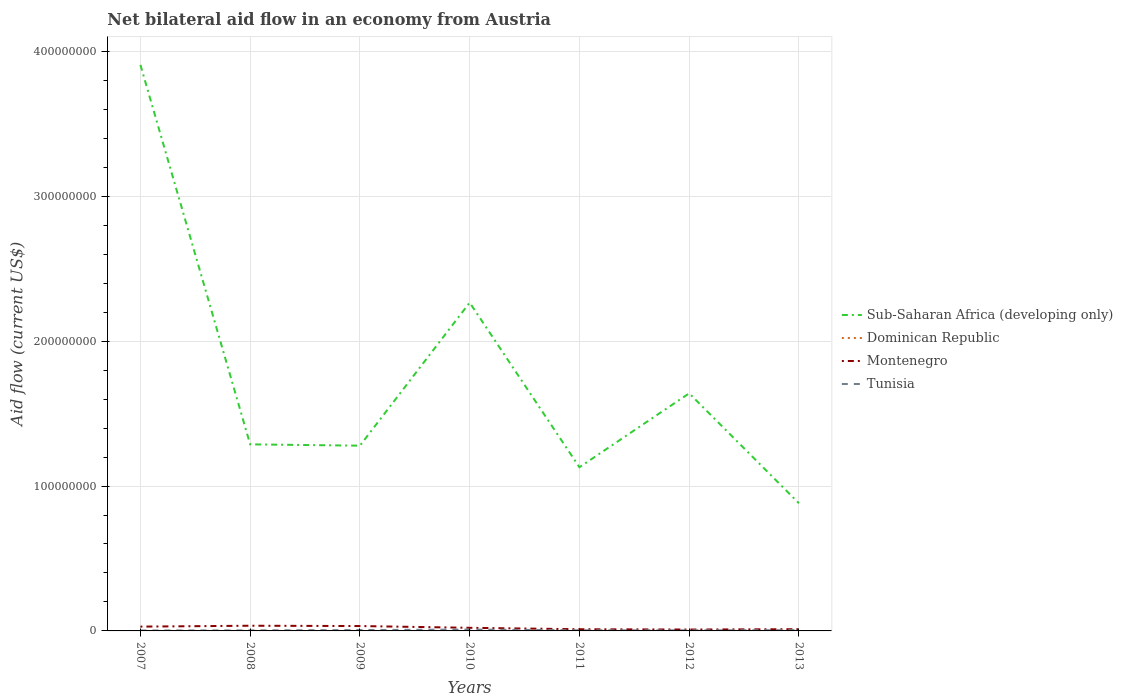How many different coloured lines are there?
Your answer should be compact. 4. Is the number of lines equal to the number of legend labels?
Your answer should be very brief. Yes. Across all years, what is the maximum net bilateral aid flow in Montenegro?
Your response must be concise. 9.60e+05. In which year was the net bilateral aid flow in Tunisia maximum?
Give a very brief answer. 2007. What is the total net bilateral aid flow in Sub-Saharan Africa (developing only) in the graph?
Make the answer very short. 2.62e+08. What is the difference between the highest and the second highest net bilateral aid flow in Montenegro?
Provide a succinct answer. 2.62e+06. What is the difference between the highest and the lowest net bilateral aid flow in Dominican Republic?
Offer a terse response. 3. How many years are there in the graph?
Your response must be concise. 7. Are the values on the major ticks of Y-axis written in scientific E-notation?
Your answer should be compact. No. Where does the legend appear in the graph?
Your answer should be very brief. Center right. How many legend labels are there?
Give a very brief answer. 4. How are the legend labels stacked?
Offer a terse response. Vertical. What is the title of the graph?
Your response must be concise. Net bilateral aid flow in an economy from Austria. Does "Morocco" appear as one of the legend labels in the graph?
Provide a short and direct response. No. What is the label or title of the X-axis?
Keep it short and to the point. Years. What is the label or title of the Y-axis?
Keep it short and to the point. Aid flow (current US$). What is the Aid flow (current US$) in Sub-Saharan Africa (developing only) in 2007?
Offer a very short reply. 3.91e+08. What is the Aid flow (current US$) in Dominican Republic in 2007?
Keep it short and to the point. 10000. What is the Aid flow (current US$) of Montenegro in 2007?
Offer a terse response. 2.97e+06. What is the Aid flow (current US$) in Tunisia in 2007?
Your answer should be very brief. 2.70e+05. What is the Aid flow (current US$) of Sub-Saharan Africa (developing only) in 2008?
Make the answer very short. 1.29e+08. What is the Aid flow (current US$) of Montenegro in 2008?
Your answer should be compact. 3.58e+06. What is the Aid flow (current US$) of Tunisia in 2008?
Your response must be concise. 3.70e+05. What is the Aid flow (current US$) in Sub-Saharan Africa (developing only) in 2009?
Offer a terse response. 1.28e+08. What is the Aid flow (current US$) of Dominican Republic in 2009?
Make the answer very short. 10000. What is the Aid flow (current US$) in Montenegro in 2009?
Keep it short and to the point. 3.37e+06. What is the Aid flow (current US$) in Sub-Saharan Africa (developing only) in 2010?
Keep it short and to the point. 2.27e+08. What is the Aid flow (current US$) of Dominican Republic in 2010?
Provide a succinct answer. 2.00e+04. What is the Aid flow (current US$) of Montenegro in 2010?
Make the answer very short. 2.15e+06. What is the Aid flow (current US$) in Tunisia in 2010?
Your answer should be very brief. 9.50e+05. What is the Aid flow (current US$) of Sub-Saharan Africa (developing only) in 2011?
Your response must be concise. 1.13e+08. What is the Aid flow (current US$) in Montenegro in 2011?
Provide a succinct answer. 1.16e+06. What is the Aid flow (current US$) of Sub-Saharan Africa (developing only) in 2012?
Offer a terse response. 1.64e+08. What is the Aid flow (current US$) in Dominican Republic in 2012?
Make the answer very short. 4.00e+04. What is the Aid flow (current US$) of Montenegro in 2012?
Give a very brief answer. 9.60e+05. What is the Aid flow (current US$) of Tunisia in 2012?
Keep it short and to the point. 4.00e+05. What is the Aid flow (current US$) of Sub-Saharan Africa (developing only) in 2013?
Keep it short and to the point. 8.81e+07. What is the Aid flow (current US$) in Dominican Republic in 2013?
Offer a terse response. 3.00e+04. What is the Aid flow (current US$) in Montenegro in 2013?
Make the answer very short. 1.19e+06. What is the Aid flow (current US$) in Tunisia in 2013?
Offer a very short reply. 5.30e+05. Across all years, what is the maximum Aid flow (current US$) of Sub-Saharan Africa (developing only)?
Your answer should be very brief. 3.91e+08. Across all years, what is the maximum Aid flow (current US$) of Dominican Republic?
Provide a short and direct response. 4.00e+04. Across all years, what is the maximum Aid flow (current US$) in Montenegro?
Your response must be concise. 3.58e+06. Across all years, what is the maximum Aid flow (current US$) in Tunisia?
Give a very brief answer. 9.50e+05. Across all years, what is the minimum Aid flow (current US$) of Sub-Saharan Africa (developing only)?
Your answer should be compact. 8.81e+07. Across all years, what is the minimum Aid flow (current US$) of Montenegro?
Provide a succinct answer. 9.60e+05. What is the total Aid flow (current US$) of Sub-Saharan Africa (developing only) in the graph?
Provide a succinct answer. 1.24e+09. What is the total Aid flow (current US$) in Montenegro in the graph?
Your answer should be compact. 1.54e+07. What is the total Aid flow (current US$) of Tunisia in the graph?
Ensure brevity in your answer.  3.56e+06. What is the difference between the Aid flow (current US$) in Sub-Saharan Africa (developing only) in 2007 and that in 2008?
Offer a terse response. 2.62e+08. What is the difference between the Aid flow (current US$) in Dominican Republic in 2007 and that in 2008?
Ensure brevity in your answer.  -10000. What is the difference between the Aid flow (current US$) in Montenegro in 2007 and that in 2008?
Offer a terse response. -6.10e+05. What is the difference between the Aid flow (current US$) in Sub-Saharan Africa (developing only) in 2007 and that in 2009?
Ensure brevity in your answer.  2.63e+08. What is the difference between the Aid flow (current US$) in Dominican Republic in 2007 and that in 2009?
Your response must be concise. 0. What is the difference between the Aid flow (current US$) in Montenegro in 2007 and that in 2009?
Your answer should be compact. -4.00e+05. What is the difference between the Aid flow (current US$) in Tunisia in 2007 and that in 2009?
Keep it short and to the point. -3.30e+05. What is the difference between the Aid flow (current US$) of Sub-Saharan Africa (developing only) in 2007 and that in 2010?
Keep it short and to the point. 1.64e+08. What is the difference between the Aid flow (current US$) in Montenegro in 2007 and that in 2010?
Your answer should be very brief. 8.20e+05. What is the difference between the Aid flow (current US$) of Tunisia in 2007 and that in 2010?
Make the answer very short. -6.80e+05. What is the difference between the Aid flow (current US$) of Sub-Saharan Africa (developing only) in 2007 and that in 2011?
Give a very brief answer. 2.78e+08. What is the difference between the Aid flow (current US$) of Montenegro in 2007 and that in 2011?
Provide a short and direct response. 1.81e+06. What is the difference between the Aid flow (current US$) in Tunisia in 2007 and that in 2011?
Your response must be concise. -1.70e+05. What is the difference between the Aid flow (current US$) of Sub-Saharan Africa (developing only) in 2007 and that in 2012?
Offer a terse response. 2.27e+08. What is the difference between the Aid flow (current US$) in Montenegro in 2007 and that in 2012?
Give a very brief answer. 2.01e+06. What is the difference between the Aid flow (current US$) in Sub-Saharan Africa (developing only) in 2007 and that in 2013?
Your answer should be very brief. 3.03e+08. What is the difference between the Aid flow (current US$) in Dominican Republic in 2007 and that in 2013?
Your answer should be very brief. -2.00e+04. What is the difference between the Aid flow (current US$) of Montenegro in 2007 and that in 2013?
Offer a terse response. 1.78e+06. What is the difference between the Aid flow (current US$) of Sub-Saharan Africa (developing only) in 2008 and that in 2009?
Your answer should be compact. 9.10e+05. What is the difference between the Aid flow (current US$) of Dominican Republic in 2008 and that in 2009?
Provide a succinct answer. 10000. What is the difference between the Aid flow (current US$) in Montenegro in 2008 and that in 2009?
Give a very brief answer. 2.10e+05. What is the difference between the Aid flow (current US$) in Sub-Saharan Africa (developing only) in 2008 and that in 2010?
Keep it short and to the point. -9.78e+07. What is the difference between the Aid flow (current US$) in Dominican Republic in 2008 and that in 2010?
Provide a succinct answer. 0. What is the difference between the Aid flow (current US$) in Montenegro in 2008 and that in 2010?
Your answer should be compact. 1.43e+06. What is the difference between the Aid flow (current US$) of Tunisia in 2008 and that in 2010?
Provide a short and direct response. -5.80e+05. What is the difference between the Aid flow (current US$) of Sub-Saharan Africa (developing only) in 2008 and that in 2011?
Give a very brief answer. 1.58e+07. What is the difference between the Aid flow (current US$) of Montenegro in 2008 and that in 2011?
Your response must be concise. 2.42e+06. What is the difference between the Aid flow (current US$) of Tunisia in 2008 and that in 2011?
Make the answer very short. -7.00e+04. What is the difference between the Aid flow (current US$) of Sub-Saharan Africa (developing only) in 2008 and that in 2012?
Offer a very short reply. -3.52e+07. What is the difference between the Aid flow (current US$) of Montenegro in 2008 and that in 2012?
Offer a very short reply. 2.62e+06. What is the difference between the Aid flow (current US$) in Sub-Saharan Africa (developing only) in 2008 and that in 2013?
Keep it short and to the point. 4.07e+07. What is the difference between the Aid flow (current US$) of Dominican Republic in 2008 and that in 2013?
Ensure brevity in your answer.  -10000. What is the difference between the Aid flow (current US$) of Montenegro in 2008 and that in 2013?
Make the answer very short. 2.39e+06. What is the difference between the Aid flow (current US$) of Sub-Saharan Africa (developing only) in 2009 and that in 2010?
Give a very brief answer. -9.88e+07. What is the difference between the Aid flow (current US$) in Montenegro in 2009 and that in 2010?
Offer a terse response. 1.22e+06. What is the difference between the Aid flow (current US$) of Tunisia in 2009 and that in 2010?
Your response must be concise. -3.50e+05. What is the difference between the Aid flow (current US$) in Sub-Saharan Africa (developing only) in 2009 and that in 2011?
Ensure brevity in your answer.  1.49e+07. What is the difference between the Aid flow (current US$) of Montenegro in 2009 and that in 2011?
Provide a succinct answer. 2.21e+06. What is the difference between the Aid flow (current US$) of Sub-Saharan Africa (developing only) in 2009 and that in 2012?
Your response must be concise. -3.61e+07. What is the difference between the Aid flow (current US$) in Dominican Republic in 2009 and that in 2012?
Provide a succinct answer. -3.00e+04. What is the difference between the Aid flow (current US$) in Montenegro in 2009 and that in 2012?
Ensure brevity in your answer.  2.41e+06. What is the difference between the Aid flow (current US$) of Sub-Saharan Africa (developing only) in 2009 and that in 2013?
Provide a short and direct response. 3.98e+07. What is the difference between the Aid flow (current US$) of Montenegro in 2009 and that in 2013?
Your answer should be compact. 2.18e+06. What is the difference between the Aid flow (current US$) in Tunisia in 2009 and that in 2013?
Keep it short and to the point. 7.00e+04. What is the difference between the Aid flow (current US$) in Sub-Saharan Africa (developing only) in 2010 and that in 2011?
Offer a very short reply. 1.14e+08. What is the difference between the Aid flow (current US$) of Dominican Republic in 2010 and that in 2011?
Offer a terse response. -10000. What is the difference between the Aid flow (current US$) of Montenegro in 2010 and that in 2011?
Your answer should be very brief. 9.90e+05. What is the difference between the Aid flow (current US$) in Tunisia in 2010 and that in 2011?
Give a very brief answer. 5.10e+05. What is the difference between the Aid flow (current US$) in Sub-Saharan Africa (developing only) in 2010 and that in 2012?
Your response must be concise. 6.26e+07. What is the difference between the Aid flow (current US$) in Montenegro in 2010 and that in 2012?
Your answer should be compact. 1.19e+06. What is the difference between the Aid flow (current US$) in Sub-Saharan Africa (developing only) in 2010 and that in 2013?
Provide a short and direct response. 1.39e+08. What is the difference between the Aid flow (current US$) in Montenegro in 2010 and that in 2013?
Offer a terse response. 9.60e+05. What is the difference between the Aid flow (current US$) of Tunisia in 2010 and that in 2013?
Provide a short and direct response. 4.20e+05. What is the difference between the Aid flow (current US$) in Sub-Saharan Africa (developing only) in 2011 and that in 2012?
Your answer should be compact. -5.10e+07. What is the difference between the Aid flow (current US$) in Tunisia in 2011 and that in 2012?
Make the answer very short. 4.00e+04. What is the difference between the Aid flow (current US$) in Sub-Saharan Africa (developing only) in 2011 and that in 2013?
Your answer should be very brief. 2.49e+07. What is the difference between the Aid flow (current US$) in Dominican Republic in 2011 and that in 2013?
Make the answer very short. 0. What is the difference between the Aid flow (current US$) of Montenegro in 2011 and that in 2013?
Your response must be concise. -3.00e+04. What is the difference between the Aid flow (current US$) in Sub-Saharan Africa (developing only) in 2012 and that in 2013?
Give a very brief answer. 7.59e+07. What is the difference between the Aid flow (current US$) in Dominican Republic in 2012 and that in 2013?
Keep it short and to the point. 10000. What is the difference between the Aid flow (current US$) of Tunisia in 2012 and that in 2013?
Your answer should be very brief. -1.30e+05. What is the difference between the Aid flow (current US$) in Sub-Saharan Africa (developing only) in 2007 and the Aid flow (current US$) in Dominican Republic in 2008?
Offer a terse response. 3.91e+08. What is the difference between the Aid flow (current US$) of Sub-Saharan Africa (developing only) in 2007 and the Aid flow (current US$) of Montenegro in 2008?
Ensure brevity in your answer.  3.87e+08. What is the difference between the Aid flow (current US$) of Sub-Saharan Africa (developing only) in 2007 and the Aid flow (current US$) of Tunisia in 2008?
Offer a very short reply. 3.90e+08. What is the difference between the Aid flow (current US$) of Dominican Republic in 2007 and the Aid flow (current US$) of Montenegro in 2008?
Your response must be concise. -3.57e+06. What is the difference between the Aid flow (current US$) in Dominican Republic in 2007 and the Aid flow (current US$) in Tunisia in 2008?
Your answer should be compact. -3.60e+05. What is the difference between the Aid flow (current US$) in Montenegro in 2007 and the Aid flow (current US$) in Tunisia in 2008?
Keep it short and to the point. 2.60e+06. What is the difference between the Aid flow (current US$) of Sub-Saharan Africa (developing only) in 2007 and the Aid flow (current US$) of Dominican Republic in 2009?
Provide a short and direct response. 3.91e+08. What is the difference between the Aid flow (current US$) in Sub-Saharan Africa (developing only) in 2007 and the Aid flow (current US$) in Montenegro in 2009?
Offer a terse response. 3.87e+08. What is the difference between the Aid flow (current US$) of Sub-Saharan Africa (developing only) in 2007 and the Aid flow (current US$) of Tunisia in 2009?
Ensure brevity in your answer.  3.90e+08. What is the difference between the Aid flow (current US$) in Dominican Republic in 2007 and the Aid flow (current US$) in Montenegro in 2009?
Your answer should be very brief. -3.36e+06. What is the difference between the Aid flow (current US$) in Dominican Republic in 2007 and the Aid flow (current US$) in Tunisia in 2009?
Keep it short and to the point. -5.90e+05. What is the difference between the Aid flow (current US$) of Montenegro in 2007 and the Aid flow (current US$) of Tunisia in 2009?
Your answer should be very brief. 2.37e+06. What is the difference between the Aid flow (current US$) in Sub-Saharan Africa (developing only) in 2007 and the Aid flow (current US$) in Dominican Republic in 2010?
Offer a terse response. 3.91e+08. What is the difference between the Aid flow (current US$) of Sub-Saharan Africa (developing only) in 2007 and the Aid flow (current US$) of Montenegro in 2010?
Give a very brief answer. 3.89e+08. What is the difference between the Aid flow (current US$) of Sub-Saharan Africa (developing only) in 2007 and the Aid flow (current US$) of Tunisia in 2010?
Your answer should be very brief. 3.90e+08. What is the difference between the Aid flow (current US$) in Dominican Republic in 2007 and the Aid flow (current US$) in Montenegro in 2010?
Offer a terse response. -2.14e+06. What is the difference between the Aid flow (current US$) in Dominican Republic in 2007 and the Aid flow (current US$) in Tunisia in 2010?
Your response must be concise. -9.40e+05. What is the difference between the Aid flow (current US$) of Montenegro in 2007 and the Aid flow (current US$) of Tunisia in 2010?
Your answer should be compact. 2.02e+06. What is the difference between the Aid flow (current US$) of Sub-Saharan Africa (developing only) in 2007 and the Aid flow (current US$) of Dominican Republic in 2011?
Your answer should be compact. 3.91e+08. What is the difference between the Aid flow (current US$) in Sub-Saharan Africa (developing only) in 2007 and the Aid flow (current US$) in Montenegro in 2011?
Your answer should be compact. 3.90e+08. What is the difference between the Aid flow (current US$) of Sub-Saharan Africa (developing only) in 2007 and the Aid flow (current US$) of Tunisia in 2011?
Your response must be concise. 3.90e+08. What is the difference between the Aid flow (current US$) of Dominican Republic in 2007 and the Aid flow (current US$) of Montenegro in 2011?
Offer a terse response. -1.15e+06. What is the difference between the Aid flow (current US$) of Dominican Republic in 2007 and the Aid flow (current US$) of Tunisia in 2011?
Give a very brief answer. -4.30e+05. What is the difference between the Aid flow (current US$) of Montenegro in 2007 and the Aid flow (current US$) of Tunisia in 2011?
Your response must be concise. 2.53e+06. What is the difference between the Aid flow (current US$) in Sub-Saharan Africa (developing only) in 2007 and the Aid flow (current US$) in Dominican Republic in 2012?
Your answer should be compact. 3.91e+08. What is the difference between the Aid flow (current US$) in Sub-Saharan Africa (developing only) in 2007 and the Aid flow (current US$) in Montenegro in 2012?
Offer a terse response. 3.90e+08. What is the difference between the Aid flow (current US$) in Sub-Saharan Africa (developing only) in 2007 and the Aid flow (current US$) in Tunisia in 2012?
Your answer should be compact. 3.90e+08. What is the difference between the Aid flow (current US$) in Dominican Republic in 2007 and the Aid flow (current US$) in Montenegro in 2012?
Your answer should be very brief. -9.50e+05. What is the difference between the Aid flow (current US$) in Dominican Republic in 2007 and the Aid flow (current US$) in Tunisia in 2012?
Offer a very short reply. -3.90e+05. What is the difference between the Aid flow (current US$) in Montenegro in 2007 and the Aid flow (current US$) in Tunisia in 2012?
Ensure brevity in your answer.  2.57e+06. What is the difference between the Aid flow (current US$) in Sub-Saharan Africa (developing only) in 2007 and the Aid flow (current US$) in Dominican Republic in 2013?
Ensure brevity in your answer.  3.91e+08. What is the difference between the Aid flow (current US$) in Sub-Saharan Africa (developing only) in 2007 and the Aid flow (current US$) in Montenegro in 2013?
Keep it short and to the point. 3.90e+08. What is the difference between the Aid flow (current US$) of Sub-Saharan Africa (developing only) in 2007 and the Aid flow (current US$) of Tunisia in 2013?
Your answer should be very brief. 3.90e+08. What is the difference between the Aid flow (current US$) of Dominican Republic in 2007 and the Aid flow (current US$) of Montenegro in 2013?
Offer a very short reply. -1.18e+06. What is the difference between the Aid flow (current US$) in Dominican Republic in 2007 and the Aid flow (current US$) in Tunisia in 2013?
Your answer should be very brief. -5.20e+05. What is the difference between the Aid flow (current US$) in Montenegro in 2007 and the Aid flow (current US$) in Tunisia in 2013?
Offer a terse response. 2.44e+06. What is the difference between the Aid flow (current US$) of Sub-Saharan Africa (developing only) in 2008 and the Aid flow (current US$) of Dominican Republic in 2009?
Your answer should be compact. 1.29e+08. What is the difference between the Aid flow (current US$) of Sub-Saharan Africa (developing only) in 2008 and the Aid flow (current US$) of Montenegro in 2009?
Give a very brief answer. 1.25e+08. What is the difference between the Aid flow (current US$) in Sub-Saharan Africa (developing only) in 2008 and the Aid flow (current US$) in Tunisia in 2009?
Provide a succinct answer. 1.28e+08. What is the difference between the Aid flow (current US$) of Dominican Republic in 2008 and the Aid flow (current US$) of Montenegro in 2009?
Your response must be concise. -3.35e+06. What is the difference between the Aid flow (current US$) of Dominican Republic in 2008 and the Aid flow (current US$) of Tunisia in 2009?
Offer a terse response. -5.80e+05. What is the difference between the Aid flow (current US$) in Montenegro in 2008 and the Aid flow (current US$) in Tunisia in 2009?
Provide a succinct answer. 2.98e+06. What is the difference between the Aid flow (current US$) of Sub-Saharan Africa (developing only) in 2008 and the Aid flow (current US$) of Dominican Republic in 2010?
Make the answer very short. 1.29e+08. What is the difference between the Aid flow (current US$) in Sub-Saharan Africa (developing only) in 2008 and the Aid flow (current US$) in Montenegro in 2010?
Your answer should be compact. 1.27e+08. What is the difference between the Aid flow (current US$) in Sub-Saharan Africa (developing only) in 2008 and the Aid flow (current US$) in Tunisia in 2010?
Make the answer very short. 1.28e+08. What is the difference between the Aid flow (current US$) of Dominican Republic in 2008 and the Aid flow (current US$) of Montenegro in 2010?
Provide a short and direct response. -2.13e+06. What is the difference between the Aid flow (current US$) in Dominican Republic in 2008 and the Aid flow (current US$) in Tunisia in 2010?
Your response must be concise. -9.30e+05. What is the difference between the Aid flow (current US$) in Montenegro in 2008 and the Aid flow (current US$) in Tunisia in 2010?
Your response must be concise. 2.63e+06. What is the difference between the Aid flow (current US$) in Sub-Saharan Africa (developing only) in 2008 and the Aid flow (current US$) in Dominican Republic in 2011?
Provide a succinct answer. 1.29e+08. What is the difference between the Aid flow (current US$) of Sub-Saharan Africa (developing only) in 2008 and the Aid flow (current US$) of Montenegro in 2011?
Provide a succinct answer. 1.28e+08. What is the difference between the Aid flow (current US$) of Sub-Saharan Africa (developing only) in 2008 and the Aid flow (current US$) of Tunisia in 2011?
Ensure brevity in your answer.  1.28e+08. What is the difference between the Aid flow (current US$) in Dominican Republic in 2008 and the Aid flow (current US$) in Montenegro in 2011?
Your answer should be very brief. -1.14e+06. What is the difference between the Aid flow (current US$) of Dominican Republic in 2008 and the Aid flow (current US$) of Tunisia in 2011?
Your answer should be compact. -4.20e+05. What is the difference between the Aid flow (current US$) of Montenegro in 2008 and the Aid flow (current US$) of Tunisia in 2011?
Offer a very short reply. 3.14e+06. What is the difference between the Aid flow (current US$) of Sub-Saharan Africa (developing only) in 2008 and the Aid flow (current US$) of Dominican Republic in 2012?
Give a very brief answer. 1.29e+08. What is the difference between the Aid flow (current US$) of Sub-Saharan Africa (developing only) in 2008 and the Aid flow (current US$) of Montenegro in 2012?
Offer a very short reply. 1.28e+08. What is the difference between the Aid flow (current US$) in Sub-Saharan Africa (developing only) in 2008 and the Aid flow (current US$) in Tunisia in 2012?
Your response must be concise. 1.28e+08. What is the difference between the Aid flow (current US$) of Dominican Republic in 2008 and the Aid flow (current US$) of Montenegro in 2012?
Your answer should be compact. -9.40e+05. What is the difference between the Aid flow (current US$) of Dominican Republic in 2008 and the Aid flow (current US$) of Tunisia in 2012?
Offer a very short reply. -3.80e+05. What is the difference between the Aid flow (current US$) of Montenegro in 2008 and the Aid flow (current US$) of Tunisia in 2012?
Your answer should be very brief. 3.18e+06. What is the difference between the Aid flow (current US$) in Sub-Saharan Africa (developing only) in 2008 and the Aid flow (current US$) in Dominican Republic in 2013?
Your response must be concise. 1.29e+08. What is the difference between the Aid flow (current US$) in Sub-Saharan Africa (developing only) in 2008 and the Aid flow (current US$) in Montenegro in 2013?
Ensure brevity in your answer.  1.28e+08. What is the difference between the Aid flow (current US$) of Sub-Saharan Africa (developing only) in 2008 and the Aid flow (current US$) of Tunisia in 2013?
Make the answer very short. 1.28e+08. What is the difference between the Aid flow (current US$) of Dominican Republic in 2008 and the Aid flow (current US$) of Montenegro in 2013?
Offer a terse response. -1.17e+06. What is the difference between the Aid flow (current US$) of Dominican Republic in 2008 and the Aid flow (current US$) of Tunisia in 2013?
Keep it short and to the point. -5.10e+05. What is the difference between the Aid flow (current US$) of Montenegro in 2008 and the Aid flow (current US$) of Tunisia in 2013?
Keep it short and to the point. 3.05e+06. What is the difference between the Aid flow (current US$) in Sub-Saharan Africa (developing only) in 2009 and the Aid flow (current US$) in Dominican Republic in 2010?
Offer a terse response. 1.28e+08. What is the difference between the Aid flow (current US$) in Sub-Saharan Africa (developing only) in 2009 and the Aid flow (current US$) in Montenegro in 2010?
Your response must be concise. 1.26e+08. What is the difference between the Aid flow (current US$) in Sub-Saharan Africa (developing only) in 2009 and the Aid flow (current US$) in Tunisia in 2010?
Your answer should be very brief. 1.27e+08. What is the difference between the Aid flow (current US$) in Dominican Republic in 2009 and the Aid flow (current US$) in Montenegro in 2010?
Provide a short and direct response. -2.14e+06. What is the difference between the Aid flow (current US$) of Dominican Republic in 2009 and the Aid flow (current US$) of Tunisia in 2010?
Ensure brevity in your answer.  -9.40e+05. What is the difference between the Aid flow (current US$) of Montenegro in 2009 and the Aid flow (current US$) of Tunisia in 2010?
Offer a very short reply. 2.42e+06. What is the difference between the Aid flow (current US$) in Sub-Saharan Africa (developing only) in 2009 and the Aid flow (current US$) in Dominican Republic in 2011?
Offer a very short reply. 1.28e+08. What is the difference between the Aid flow (current US$) of Sub-Saharan Africa (developing only) in 2009 and the Aid flow (current US$) of Montenegro in 2011?
Give a very brief answer. 1.27e+08. What is the difference between the Aid flow (current US$) of Sub-Saharan Africa (developing only) in 2009 and the Aid flow (current US$) of Tunisia in 2011?
Provide a succinct answer. 1.27e+08. What is the difference between the Aid flow (current US$) in Dominican Republic in 2009 and the Aid flow (current US$) in Montenegro in 2011?
Provide a short and direct response. -1.15e+06. What is the difference between the Aid flow (current US$) of Dominican Republic in 2009 and the Aid flow (current US$) of Tunisia in 2011?
Provide a short and direct response. -4.30e+05. What is the difference between the Aid flow (current US$) in Montenegro in 2009 and the Aid flow (current US$) in Tunisia in 2011?
Provide a succinct answer. 2.93e+06. What is the difference between the Aid flow (current US$) of Sub-Saharan Africa (developing only) in 2009 and the Aid flow (current US$) of Dominican Republic in 2012?
Ensure brevity in your answer.  1.28e+08. What is the difference between the Aid flow (current US$) in Sub-Saharan Africa (developing only) in 2009 and the Aid flow (current US$) in Montenegro in 2012?
Provide a short and direct response. 1.27e+08. What is the difference between the Aid flow (current US$) in Sub-Saharan Africa (developing only) in 2009 and the Aid flow (current US$) in Tunisia in 2012?
Ensure brevity in your answer.  1.27e+08. What is the difference between the Aid flow (current US$) in Dominican Republic in 2009 and the Aid flow (current US$) in Montenegro in 2012?
Provide a short and direct response. -9.50e+05. What is the difference between the Aid flow (current US$) in Dominican Republic in 2009 and the Aid flow (current US$) in Tunisia in 2012?
Ensure brevity in your answer.  -3.90e+05. What is the difference between the Aid flow (current US$) in Montenegro in 2009 and the Aid flow (current US$) in Tunisia in 2012?
Make the answer very short. 2.97e+06. What is the difference between the Aid flow (current US$) of Sub-Saharan Africa (developing only) in 2009 and the Aid flow (current US$) of Dominican Republic in 2013?
Keep it short and to the point. 1.28e+08. What is the difference between the Aid flow (current US$) in Sub-Saharan Africa (developing only) in 2009 and the Aid flow (current US$) in Montenegro in 2013?
Give a very brief answer. 1.27e+08. What is the difference between the Aid flow (current US$) in Sub-Saharan Africa (developing only) in 2009 and the Aid flow (current US$) in Tunisia in 2013?
Make the answer very short. 1.27e+08. What is the difference between the Aid flow (current US$) of Dominican Republic in 2009 and the Aid flow (current US$) of Montenegro in 2013?
Keep it short and to the point. -1.18e+06. What is the difference between the Aid flow (current US$) of Dominican Republic in 2009 and the Aid flow (current US$) of Tunisia in 2013?
Your response must be concise. -5.20e+05. What is the difference between the Aid flow (current US$) of Montenegro in 2009 and the Aid flow (current US$) of Tunisia in 2013?
Provide a short and direct response. 2.84e+06. What is the difference between the Aid flow (current US$) in Sub-Saharan Africa (developing only) in 2010 and the Aid flow (current US$) in Dominican Republic in 2011?
Your answer should be very brief. 2.27e+08. What is the difference between the Aid flow (current US$) in Sub-Saharan Africa (developing only) in 2010 and the Aid flow (current US$) in Montenegro in 2011?
Provide a succinct answer. 2.25e+08. What is the difference between the Aid flow (current US$) of Sub-Saharan Africa (developing only) in 2010 and the Aid flow (current US$) of Tunisia in 2011?
Ensure brevity in your answer.  2.26e+08. What is the difference between the Aid flow (current US$) in Dominican Republic in 2010 and the Aid flow (current US$) in Montenegro in 2011?
Offer a terse response. -1.14e+06. What is the difference between the Aid flow (current US$) in Dominican Republic in 2010 and the Aid flow (current US$) in Tunisia in 2011?
Your response must be concise. -4.20e+05. What is the difference between the Aid flow (current US$) of Montenegro in 2010 and the Aid flow (current US$) of Tunisia in 2011?
Offer a terse response. 1.71e+06. What is the difference between the Aid flow (current US$) of Sub-Saharan Africa (developing only) in 2010 and the Aid flow (current US$) of Dominican Republic in 2012?
Make the answer very short. 2.27e+08. What is the difference between the Aid flow (current US$) in Sub-Saharan Africa (developing only) in 2010 and the Aid flow (current US$) in Montenegro in 2012?
Your answer should be compact. 2.26e+08. What is the difference between the Aid flow (current US$) of Sub-Saharan Africa (developing only) in 2010 and the Aid flow (current US$) of Tunisia in 2012?
Make the answer very short. 2.26e+08. What is the difference between the Aid flow (current US$) in Dominican Republic in 2010 and the Aid flow (current US$) in Montenegro in 2012?
Provide a succinct answer. -9.40e+05. What is the difference between the Aid flow (current US$) of Dominican Republic in 2010 and the Aid flow (current US$) of Tunisia in 2012?
Offer a very short reply. -3.80e+05. What is the difference between the Aid flow (current US$) of Montenegro in 2010 and the Aid flow (current US$) of Tunisia in 2012?
Keep it short and to the point. 1.75e+06. What is the difference between the Aid flow (current US$) in Sub-Saharan Africa (developing only) in 2010 and the Aid flow (current US$) in Dominican Republic in 2013?
Your answer should be compact. 2.27e+08. What is the difference between the Aid flow (current US$) in Sub-Saharan Africa (developing only) in 2010 and the Aid flow (current US$) in Montenegro in 2013?
Your answer should be compact. 2.25e+08. What is the difference between the Aid flow (current US$) of Sub-Saharan Africa (developing only) in 2010 and the Aid flow (current US$) of Tunisia in 2013?
Offer a terse response. 2.26e+08. What is the difference between the Aid flow (current US$) in Dominican Republic in 2010 and the Aid flow (current US$) in Montenegro in 2013?
Offer a terse response. -1.17e+06. What is the difference between the Aid flow (current US$) in Dominican Republic in 2010 and the Aid flow (current US$) in Tunisia in 2013?
Ensure brevity in your answer.  -5.10e+05. What is the difference between the Aid flow (current US$) in Montenegro in 2010 and the Aid flow (current US$) in Tunisia in 2013?
Your answer should be very brief. 1.62e+06. What is the difference between the Aid flow (current US$) in Sub-Saharan Africa (developing only) in 2011 and the Aid flow (current US$) in Dominican Republic in 2012?
Your answer should be compact. 1.13e+08. What is the difference between the Aid flow (current US$) in Sub-Saharan Africa (developing only) in 2011 and the Aid flow (current US$) in Montenegro in 2012?
Make the answer very short. 1.12e+08. What is the difference between the Aid flow (current US$) in Sub-Saharan Africa (developing only) in 2011 and the Aid flow (current US$) in Tunisia in 2012?
Provide a succinct answer. 1.13e+08. What is the difference between the Aid flow (current US$) in Dominican Republic in 2011 and the Aid flow (current US$) in Montenegro in 2012?
Offer a terse response. -9.30e+05. What is the difference between the Aid flow (current US$) in Dominican Republic in 2011 and the Aid flow (current US$) in Tunisia in 2012?
Provide a succinct answer. -3.70e+05. What is the difference between the Aid flow (current US$) of Montenegro in 2011 and the Aid flow (current US$) of Tunisia in 2012?
Provide a succinct answer. 7.60e+05. What is the difference between the Aid flow (current US$) in Sub-Saharan Africa (developing only) in 2011 and the Aid flow (current US$) in Dominican Republic in 2013?
Your answer should be compact. 1.13e+08. What is the difference between the Aid flow (current US$) in Sub-Saharan Africa (developing only) in 2011 and the Aid flow (current US$) in Montenegro in 2013?
Keep it short and to the point. 1.12e+08. What is the difference between the Aid flow (current US$) in Sub-Saharan Africa (developing only) in 2011 and the Aid flow (current US$) in Tunisia in 2013?
Give a very brief answer. 1.12e+08. What is the difference between the Aid flow (current US$) of Dominican Republic in 2011 and the Aid flow (current US$) of Montenegro in 2013?
Make the answer very short. -1.16e+06. What is the difference between the Aid flow (current US$) of Dominican Republic in 2011 and the Aid flow (current US$) of Tunisia in 2013?
Offer a terse response. -5.00e+05. What is the difference between the Aid flow (current US$) of Montenegro in 2011 and the Aid flow (current US$) of Tunisia in 2013?
Make the answer very short. 6.30e+05. What is the difference between the Aid flow (current US$) in Sub-Saharan Africa (developing only) in 2012 and the Aid flow (current US$) in Dominican Republic in 2013?
Offer a terse response. 1.64e+08. What is the difference between the Aid flow (current US$) of Sub-Saharan Africa (developing only) in 2012 and the Aid flow (current US$) of Montenegro in 2013?
Keep it short and to the point. 1.63e+08. What is the difference between the Aid flow (current US$) of Sub-Saharan Africa (developing only) in 2012 and the Aid flow (current US$) of Tunisia in 2013?
Provide a short and direct response. 1.63e+08. What is the difference between the Aid flow (current US$) in Dominican Republic in 2012 and the Aid flow (current US$) in Montenegro in 2013?
Your response must be concise. -1.15e+06. What is the difference between the Aid flow (current US$) in Dominican Republic in 2012 and the Aid flow (current US$) in Tunisia in 2013?
Your answer should be compact. -4.90e+05. What is the difference between the Aid flow (current US$) in Montenegro in 2012 and the Aid flow (current US$) in Tunisia in 2013?
Make the answer very short. 4.30e+05. What is the average Aid flow (current US$) of Sub-Saharan Africa (developing only) per year?
Make the answer very short. 1.77e+08. What is the average Aid flow (current US$) in Dominican Republic per year?
Give a very brief answer. 2.29e+04. What is the average Aid flow (current US$) of Montenegro per year?
Your answer should be compact. 2.20e+06. What is the average Aid flow (current US$) in Tunisia per year?
Make the answer very short. 5.09e+05. In the year 2007, what is the difference between the Aid flow (current US$) in Sub-Saharan Africa (developing only) and Aid flow (current US$) in Dominican Republic?
Provide a succinct answer. 3.91e+08. In the year 2007, what is the difference between the Aid flow (current US$) of Sub-Saharan Africa (developing only) and Aid flow (current US$) of Montenegro?
Your answer should be compact. 3.88e+08. In the year 2007, what is the difference between the Aid flow (current US$) in Sub-Saharan Africa (developing only) and Aid flow (current US$) in Tunisia?
Ensure brevity in your answer.  3.90e+08. In the year 2007, what is the difference between the Aid flow (current US$) of Dominican Republic and Aid flow (current US$) of Montenegro?
Keep it short and to the point. -2.96e+06. In the year 2007, what is the difference between the Aid flow (current US$) in Dominican Republic and Aid flow (current US$) in Tunisia?
Offer a very short reply. -2.60e+05. In the year 2007, what is the difference between the Aid flow (current US$) of Montenegro and Aid flow (current US$) of Tunisia?
Give a very brief answer. 2.70e+06. In the year 2008, what is the difference between the Aid flow (current US$) in Sub-Saharan Africa (developing only) and Aid flow (current US$) in Dominican Republic?
Offer a very short reply. 1.29e+08. In the year 2008, what is the difference between the Aid flow (current US$) in Sub-Saharan Africa (developing only) and Aid flow (current US$) in Montenegro?
Give a very brief answer. 1.25e+08. In the year 2008, what is the difference between the Aid flow (current US$) of Sub-Saharan Africa (developing only) and Aid flow (current US$) of Tunisia?
Make the answer very short. 1.28e+08. In the year 2008, what is the difference between the Aid flow (current US$) in Dominican Republic and Aid flow (current US$) in Montenegro?
Keep it short and to the point. -3.56e+06. In the year 2008, what is the difference between the Aid flow (current US$) of Dominican Republic and Aid flow (current US$) of Tunisia?
Offer a very short reply. -3.50e+05. In the year 2008, what is the difference between the Aid flow (current US$) in Montenegro and Aid flow (current US$) in Tunisia?
Your answer should be compact. 3.21e+06. In the year 2009, what is the difference between the Aid flow (current US$) in Sub-Saharan Africa (developing only) and Aid flow (current US$) in Dominican Republic?
Your answer should be very brief. 1.28e+08. In the year 2009, what is the difference between the Aid flow (current US$) of Sub-Saharan Africa (developing only) and Aid flow (current US$) of Montenegro?
Your answer should be very brief. 1.24e+08. In the year 2009, what is the difference between the Aid flow (current US$) in Sub-Saharan Africa (developing only) and Aid flow (current US$) in Tunisia?
Offer a very short reply. 1.27e+08. In the year 2009, what is the difference between the Aid flow (current US$) of Dominican Republic and Aid flow (current US$) of Montenegro?
Keep it short and to the point. -3.36e+06. In the year 2009, what is the difference between the Aid flow (current US$) in Dominican Republic and Aid flow (current US$) in Tunisia?
Your response must be concise. -5.90e+05. In the year 2009, what is the difference between the Aid flow (current US$) in Montenegro and Aid flow (current US$) in Tunisia?
Your response must be concise. 2.77e+06. In the year 2010, what is the difference between the Aid flow (current US$) of Sub-Saharan Africa (developing only) and Aid flow (current US$) of Dominican Republic?
Give a very brief answer. 2.27e+08. In the year 2010, what is the difference between the Aid flow (current US$) of Sub-Saharan Africa (developing only) and Aid flow (current US$) of Montenegro?
Your answer should be very brief. 2.24e+08. In the year 2010, what is the difference between the Aid flow (current US$) of Sub-Saharan Africa (developing only) and Aid flow (current US$) of Tunisia?
Make the answer very short. 2.26e+08. In the year 2010, what is the difference between the Aid flow (current US$) in Dominican Republic and Aid flow (current US$) in Montenegro?
Give a very brief answer. -2.13e+06. In the year 2010, what is the difference between the Aid flow (current US$) of Dominican Republic and Aid flow (current US$) of Tunisia?
Make the answer very short. -9.30e+05. In the year 2010, what is the difference between the Aid flow (current US$) of Montenegro and Aid flow (current US$) of Tunisia?
Provide a succinct answer. 1.20e+06. In the year 2011, what is the difference between the Aid flow (current US$) of Sub-Saharan Africa (developing only) and Aid flow (current US$) of Dominican Republic?
Make the answer very short. 1.13e+08. In the year 2011, what is the difference between the Aid flow (current US$) in Sub-Saharan Africa (developing only) and Aid flow (current US$) in Montenegro?
Ensure brevity in your answer.  1.12e+08. In the year 2011, what is the difference between the Aid flow (current US$) of Sub-Saharan Africa (developing only) and Aid flow (current US$) of Tunisia?
Your answer should be compact. 1.13e+08. In the year 2011, what is the difference between the Aid flow (current US$) of Dominican Republic and Aid flow (current US$) of Montenegro?
Provide a short and direct response. -1.13e+06. In the year 2011, what is the difference between the Aid flow (current US$) of Dominican Republic and Aid flow (current US$) of Tunisia?
Make the answer very short. -4.10e+05. In the year 2011, what is the difference between the Aid flow (current US$) of Montenegro and Aid flow (current US$) of Tunisia?
Give a very brief answer. 7.20e+05. In the year 2012, what is the difference between the Aid flow (current US$) of Sub-Saharan Africa (developing only) and Aid flow (current US$) of Dominican Republic?
Offer a terse response. 1.64e+08. In the year 2012, what is the difference between the Aid flow (current US$) of Sub-Saharan Africa (developing only) and Aid flow (current US$) of Montenegro?
Offer a terse response. 1.63e+08. In the year 2012, what is the difference between the Aid flow (current US$) in Sub-Saharan Africa (developing only) and Aid flow (current US$) in Tunisia?
Your answer should be compact. 1.64e+08. In the year 2012, what is the difference between the Aid flow (current US$) of Dominican Republic and Aid flow (current US$) of Montenegro?
Offer a terse response. -9.20e+05. In the year 2012, what is the difference between the Aid flow (current US$) in Dominican Republic and Aid flow (current US$) in Tunisia?
Offer a very short reply. -3.60e+05. In the year 2012, what is the difference between the Aid flow (current US$) of Montenegro and Aid flow (current US$) of Tunisia?
Ensure brevity in your answer.  5.60e+05. In the year 2013, what is the difference between the Aid flow (current US$) of Sub-Saharan Africa (developing only) and Aid flow (current US$) of Dominican Republic?
Your answer should be very brief. 8.81e+07. In the year 2013, what is the difference between the Aid flow (current US$) of Sub-Saharan Africa (developing only) and Aid flow (current US$) of Montenegro?
Give a very brief answer. 8.69e+07. In the year 2013, what is the difference between the Aid flow (current US$) in Sub-Saharan Africa (developing only) and Aid flow (current US$) in Tunisia?
Offer a terse response. 8.76e+07. In the year 2013, what is the difference between the Aid flow (current US$) of Dominican Republic and Aid flow (current US$) of Montenegro?
Offer a very short reply. -1.16e+06. In the year 2013, what is the difference between the Aid flow (current US$) in Dominican Republic and Aid flow (current US$) in Tunisia?
Offer a very short reply. -5.00e+05. In the year 2013, what is the difference between the Aid flow (current US$) in Montenegro and Aid flow (current US$) in Tunisia?
Your answer should be very brief. 6.60e+05. What is the ratio of the Aid flow (current US$) of Sub-Saharan Africa (developing only) in 2007 to that in 2008?
Your answer should be compact. 3.03. What is the ratio of the Aid flow (current US$) in Montenegro in 2007 to that in 2008?
Your answer should be compact. 0.83. What is the ratio of the Aid flow (current US$) of Tunisia in 2007 to that in 2008?
Keep it short and to the point. 0.73. What is the ratio of the Aid flow (current US$) of Sub-Saharan Africa (developing only) in 2007 to that in 2009?
Ensure brevity in your answer.  3.06. What is the ratio of the Aid flow (current US$) of Dominican Republic in 2007 to that in 2009?
Make the answer very short. 1. What is the ratio of the Aid flow (current US$) of Montenegro in 2007 to that in 2009?
Give a very brief answer. 0.88. What is the ratio of the Aid flow (current US$) of Tunisia in 2007 to that in 2009?
Provide a short and direct response. 0.45. What is the ratio of the Aid flow (current US$) of Sub-Saharan Africa (developing only) in 2007 to that in 2010?
Make the answer very short. 1.72. What is the ratio of the Aid flow (current US$) in Montenegro in 2007 to that in 2010?
Your response must be concise. 1.38. What is the ratio of the Aid flow (current US$) in Tunisia in 2007 to that in 2010?
Offer a terse response. 0.28. What is the ratio of the Aid flow (current US$) of Sub-Saharan Africa (developing only) in 2007 to that in 2011?
Your answer should be very brief. 3.46. What is the ratio of the Aid flow (current US$) in Dominican Republic in 2007 to that in 2011?
Make the answer very short. 0.33. What is the ratio of the Aid flow (current US$) in Montenegro in 2007 to that in 2011?
Ensure brevity in your answer.  2.56. What is the ratio of the Aid flow (current US$) in Tunisia in 2007 to that in 2011?
Your answer should be compact. 0.61. What is the ratio of the Aid flow (current US$) of Sub-Saharan Africa (developing only) in 2007 to that in 2012?
Make the answer very short. 2.38. What is the ratio of the Aid flow (current US$) in Montenegro in 2007 to that in 2012?
Make the answer very short. 3.09. What is the ratio of the Aid flow (current US$) of Tunisia in 2007 to that in 2012?
Provide a succinct answer. 0.68. What is the ratio of the Aid flow (current US$) in Sub-Saharan Africa (developing only) in 2007 to that in 2013?
Provide a succinct answer. 4.43. What is the ratio of the Aid flow (current US$) of Montenegro in 2007 to that in 2013?
Ensure brevity in your answer.  2.5. What is the ratio of the Aid flow (current US$) in Tunisia in 2007 to that in 2013?
Your answer should be very brief. 0.51. What is the ratio of the Aid flow (current US$) of Sub-Saharan Africa (developing only) in 2008 to that in 2009?
Ensure brevity in your answer.  1.01. What is the ratio of the Aid flow (current US$) in Dominican Republic in 2008 to that in 2009?
Give a very brief answer. 2. What is the ratio of the Aid flow (current US$) in Montenegro in 2008 to that in 2009?
Offer a terse response. 1.06. What is the ratio of the Aid flow (current US$) in Tunisia in 2008 to that in 2009?
Your response must be concise. 0.62. What is the ratio of the Aid flow (current US$) of Sub-Saharan Africa (developing only) in 2008 to that in 2010?
Offer a very short reply. 0.57. What is the ratio of the Aid flow (current US$) of Dominican Republic in 2008 to that in 2010?
Ensure brevity in your answer.  1. What is the ratio of the Aid flow (current US$) in Montenegro in 2008 to that in 2010?
Your answer should be very brief. 1.67. What is the ratio of the Aid flow (current US$) of Tunisia in 2008 to that in 2010?
Your answer should be compact. 0.39. What is the ratio of the Aid flow (current US$) in Sub-Saharan Africa (developing only) in 2008 to that in 2011?
Provide a short and direct response. 1.14. What is the ratio of the Aid flow (current US$) in Dominican Republic in 2008 to that in 2011?
Keep it short and to the point. 0.67. What is the ratio of the Aid flow (current US$) in Montenegro in 2008 to that in 2011?
Offer a very short reply. 3.09. What is the ratio of the Aid flow (current US$) of Tunisia in 2008 to that in 2011?
Keep it short and to the point. 0.84. What is the ratio of the Aid flow (current US$) of Sub-Saharan Africa (developing only) in 2008 to that in 2012?
Your answer should be very brief. 0.79. What is the ratio of the Aid flow (current US$) of Dominican Republic in 2008 to that in 2012?
Your response must be concise. 0.5. What is the ratio of the Aid flow (current US$) in Montenegro in 2008 to that in 2012?
Make the answer very short. 3.73. What is the ratio of the Aid flow (current US$) in Tunisia in 2008 to that in 2012?
Offer a terse response. 0.93. What is the ratio of the Aid flow (current US$) in Sub-Saharan Africa (developing only) in 2008 to that in 2013?
Make the answer very short. 1.46. What is the ratio of the Aid flow (current US$) of Montenegro in 2008 to that in 2013?
Provide a short and direct response. 3.01. What is the ratio of the Aid flow (current US$) in Tunisia in 2008 to that in 2013?
Make the answer very short. 0.7. What is the ratio of the Aid flow (current US$) in Sub-Saharan Africa (developing only) in 2009 to that in 2010?
Your answer should be very brief. 0.56. What is the ratio of the Aid flow (current US$) of Dominican Republic in 2009 to that in 2010?
Keep it short and to the point. 0.5. What is the ratio of the Aid flow (current US$) in Montenegro in 2009 to that in 2010?
Offer a terse response. 1.57. What is the ratio of the Aid flow (current US$) in Tunisia in 2009 to that in 2010?
Provide a succinct answer. 0.63. What is the ratio of the Aid flow (current US$) of Sub-Saharan Africa (developing only) in 2009 to that in 2011?
Make the answer very short. 1.13. What is the ratio of the Aid flow (current US$) in Dominican Republic in 2009 to that in 2011?
Keep it short and to the point. 0.33. What is the ratio of the Aid flow (current US$) in Montenegro in 2009 to that in 2011?
Offer a terse response. 2.91. What is the ratio of the Aid flow (current US$) in Tunisia in 2009 to that in 2011?
Offer a very short reply. 1.36. What is the ratio of the Aid flow (current US$) of Sub-Saharan Africa (developing only) in 2009 to that in 2012?
Give a very brief answer. 0.78. What is the ratio of the Aid flow (current US$) of Dominican Republic in 2009 to that in 2012?
Keep it short and to the point. 0.25. What is the ratio of the Aid flow (current US$) in Montenegro in 2009 to that in 2012?
Provide a short and direct response. 3.51. What is the ratio of the Aid flow (current US$) in Tunisia in 2009 to that in 2012?
Your answer should be very brief. 1.5. What is the ratio of the Aid flow (current US$) in Sub-Saharan Africa (developing only) in 2009 to that in 2013?
Ensure brevity in your answer.  1.45. What is the ratio of the Aid flow (current US$) of Montenegro in 2009 to that in 2013?
Your answer should be very brief. 2.83. What is the ratio of the Aid flow (current US$) of Tunisia in 2009 to that in 2013?
Your answer should be compact. 1.13. What is the ratio of the Aid flow (current US$) of Sub-Saharan Africa (developing only) in 2010 to that in 2011?
Keep it short and to the point. 2.01. What is the ratio of the Aid flow (current US$) of Montenegro in 2010 to that in 2011?
Provide a succinct answer. 1.85. What is the ratio of the Aid flow (current US$) in Tunisia in 2010 to that in 2011?
Ensure brevity in your answer.  2.16. What is the ratio of the Aid flow (current US$) in Sub-Saharan Africa (developing only) in 2010 to that in 2012?
Provide a short and direct response. 1.38. What is the ratio of the Aid flow (current US$) of Montenegro in 2010 to that in 2012?
Ensure brevity in your answer.  2.24. What is the ratio of the Aid flow (current US$) in Tunisia in 2010 to that in 2012?
Offer a terse response. 2.38. What is the ratio of the Aid flow (current US$) of Sub-Saharan Africa (developing only) in 2010 to that in 2013?
Keep it short and to the point. 2.57. What is the ratio of the Aid flow (current US$) of Montenegro in 2010 to that in 2013?
Your answer should be compact. 1.81. What is the ratio of the Aid flow (current US$) in Tunisia in 2010 to that in 2013?
Make the answer very short. 1.79. What is the ratio of the Aid flow (current US$) of Sub-Saharan Africa (developing only) in 2011 to that in 2012?
Provide a succinct answer. 0.69. What is the ratio of the Aid flow (current US$) of Montenegro in 2011 to that in 2012?
Give a very brief answer. 1.21. What is the ratio of the Aid flow (current US$) in Sub-Saharan Africa (developing only) in 2011 to that in 2013?
Offer a terse response. 1.28. What is the ratio of the Aid flow (current US$) of Dominican Republic in 2011 to that in 2013?
Make the answer very short. 1. What is the ratio of the Aid flow (current US$) of Montenegro in 2011 to that in 2013?
Provide a short and direct response. 0.97. What is the ratio of the Aid flow (current US$) of Tunisia in 2011 to that in 2013?
Your answer should be very brief. 0.83. What is the ratio of the Aid flow (current US$) in Sub-Saharan Africa (developing only) in 2012 to that in 2013?
Give a very brief answer. 1.86. What is the ratio of the Aid flow (current US$) in Dominican Republic in 2012 to that in 2013?
Make the answer very short. 1.33. What is the ratio of the Aid flow (current US$) of Montenegro in 2012 to that in 2013?
Keep it short and to the point. 0.81. What is the ratio of the Aid flow (current US$) in Tunisia in 2012 to that in 2013?
Your answer should be compact. 0.75. What is the difference between the highest and the second highest Aid flow (current US$) of Sub-Saharan Africa (developing only)?
Provide a succinct answer. 1.64e+08. What is the difference between the highest and the second highest Aid flow (current US$) in Montenegro?
Offer a very short reply. 2.10e+05. What is the difference between the highest and the second highest Aid flow (current US$) in Tunisia?
Ensure brevity in your answer.  3.50e+05. What is the difference between the highest and the lowest Aid flow (current US$) in Sub-Saharan Africa (developing only)?
Your answer should be very brief. 3.03e+08. What is the difference between the highest and the lowest Aid flow (current US$) in Montenegro?
Your response must be concise. 2.62e+06. What is the difference between the highest and the lowest Aid flow (current US$) in Tunisia?
Offer a very short reply. 6.80e+05. 